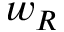Convert formula to latex. <formula><loc_0><loc_0><loc_500><loc_500>w _ { R }</formula> 